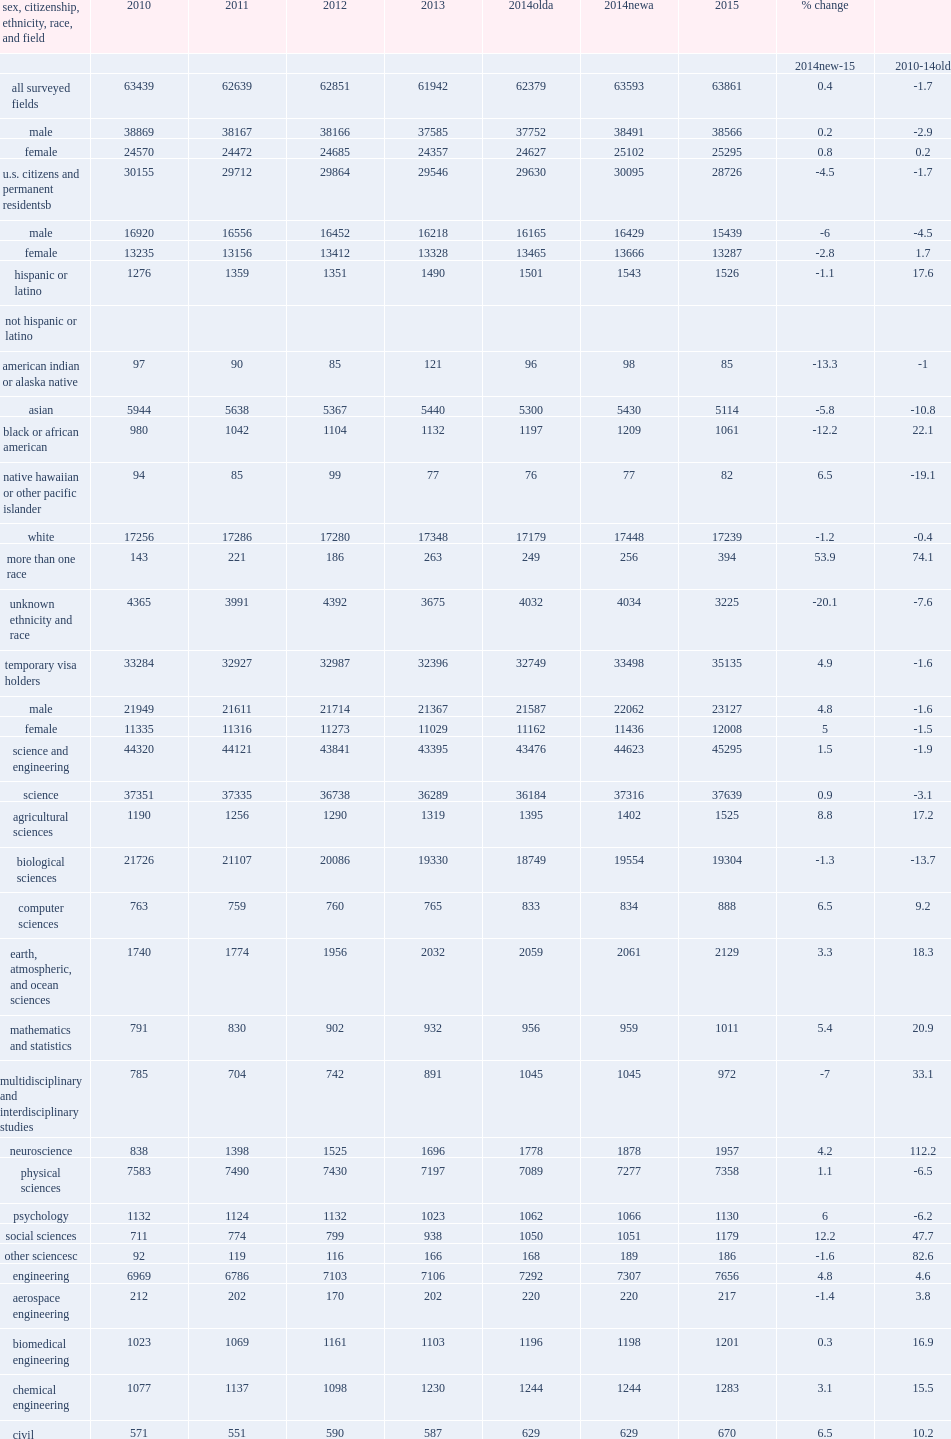In 2015, how many seh postdocs at u.s. academic institutions (and their affiliates, such as research centers and hospitals) with seh graduate programs? 63861.0. How many percent did the total number increase from the previous year? 0.004214. What was the total number increased from the previous year? 268. 